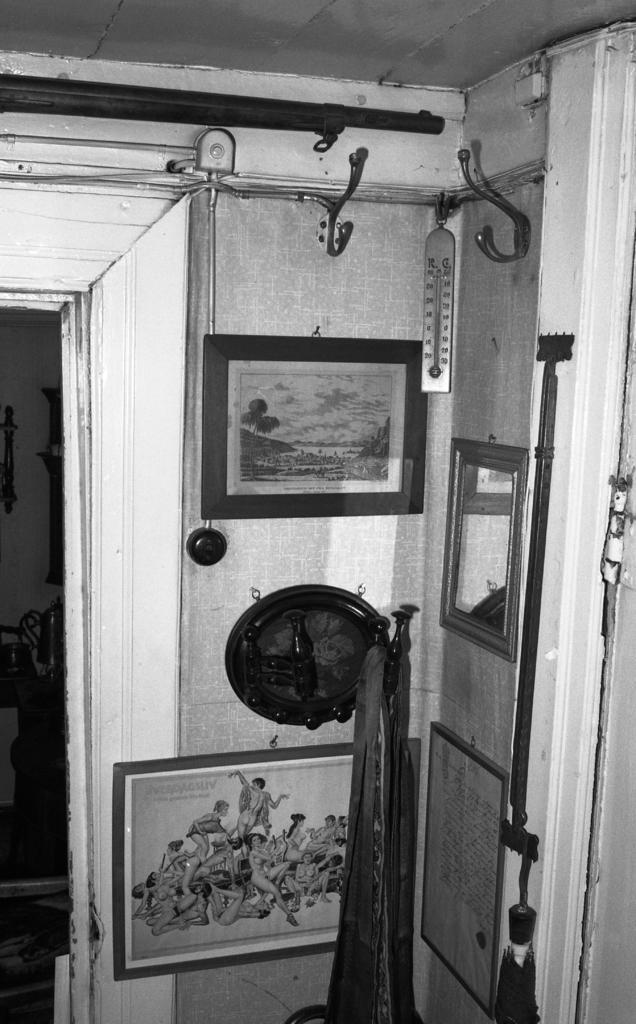Can you describe this image briefly? This picture describes about inside of the room, in this we can find few paintings and other things on the wall, and also we can see few metal rods. 